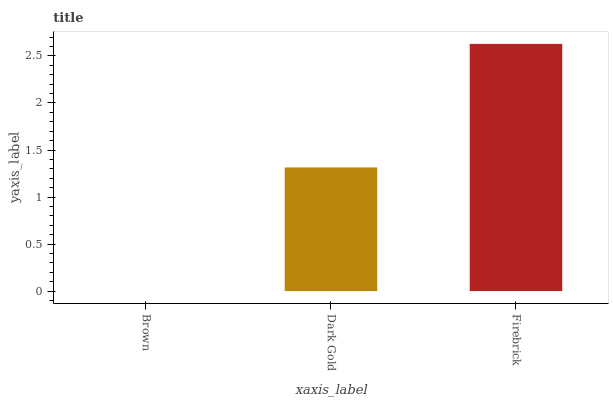Is Brown the minimum?
Answer yes or no. Yes. Is Firebrick the maximum?
Answer yes or no. Yes. Is Dark Gold the minimum?
Answer yes or no. No. Is Dark Gold the maximum?
Answer yes or no. No. Is Dark Gold greater than Brown?
Answer yes or no. Yes. Is Brown less than Dark Gold?
Answer yes or no. Yes. Is Brown greater than Dark Gold?
Answer yes or no. No. Is Dark Gold less than Brown?
Answer yes or no. No. Is Dark Gold the high median?
Answer yes or no. Yes. Is Dark Gold the low median?
Answer yes or no. Yes. Is Firebrick the high median?
Answer yes or no. No. Is Firebrick the low median?
Answer yes or no. No. 